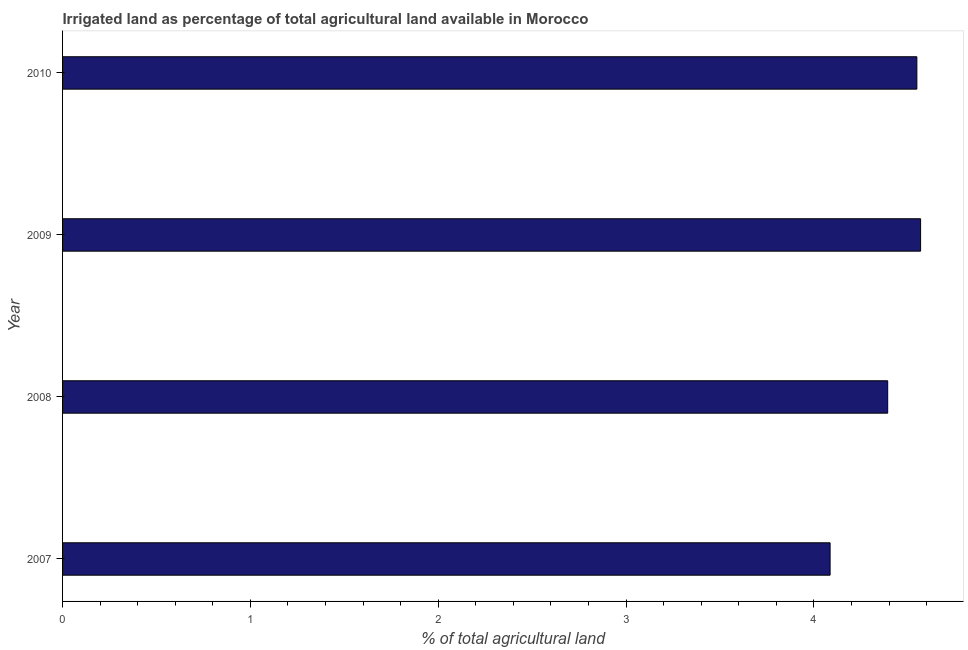What is the title of the graph?
Offer a terse response. Irrigated land as percentage of total agricultural land available in Morocco. What is the label or title of the X-axis?
Make the answer very short. % of total agricultural land. What is the label or title of the Y-axis?
Your answer should be very brief. Year. What is the percentage of agricultural irrigated land in 2008?
Ensure brevity in your answer.  4.39. Across all years, what is the maximum percentage of agricultural irrigated land?
Provide a succinct answer. 4.57. Across all years, what is the minimum percentage of agricultural irrigated land?
Your answer should be very brief. 4.09. What is the sum of the percentage of agricultural irrigated land?
Make the answer very short. 17.59. What is the difference between the percentage of agricultural irrigated land in 2008 and 2009?
Ensure brevity in your answer.  -0.17. What is the average percentage of agricultural irrigated land per year?
Ensure brevity in your answer.  4.4. What is the median percentage of agricultural irrigated land?
Give a very brief answer. 4.47. In how many years, is the percentage of agricultural irrigated land greater than 0.4 %?
Offer a very short reply. 4. What is the ratio of the percentage of agricultural irrigated land in 2007 to that in 2010?
Provide a succinct answer. 0.9. Is the percentage of agricultural irrigated land in 2008 less than that in 2009?
Provide a short and direct response. Yes. Is the difference between the percentage of agricultural irrigated land in 2007 and 2009 greater than the difference between any two years?
Offer a terse response. Yes. Is the sum of the percentage of agricultural irrigated land in 2008 and 2009 greater than the maximum percentage of agricultural irrigated land across all years?
Provide a succinct answer. Yes. What is the difference between the highest and the lowest percentage of agricultural irrigated land?
Your answer should be very brief. 0.48. In how many years, is the percentage of agricultural irrigated land greater than the average percentage of agricultural irrigated land taken over all years?
Offer a terse response. 2. What is the difference between two consecutive major ticks on the X-axis?
Your answer should be compact. 1. Are the values on the major ticks of X-axis written in scientific E-notation?
Provide a succinct answer. No. What is the % of total agricultural land of 2007?
Make the answer very short. 4.09. What is the % of total agricultural land of 2008?
Provide a succinct answer. 4.39. What is the % of total agricultural land in 2009?
Offer a very short reply. 4.57. What is the % of total agricultural land in 2010?
Make the answer very short. 4.55. What is the difference between the % of total agricultural land in 2007 and 2008?
Provide a succinct answer. -0.31. What is the difference between the % of total agricultural land in 2007 and 2009?
Make the answer very short. -0.48. What is the difference between the % of total agricultural land in 2007 and 2010?
Provide a succinct answer. -0.46. What is the difference between the % of total agricultural land in 2008 and 2009?
Provide a short and direct response. -0.18. What is the difference between the % of total agricultural land in 2008 and 2010?
Make the answer very short. -0.16. What is the difference between the % of total agricultural land in 2009 and 2010?
Your answer should be very brief. 0.02. What is the ratio of the % of total agricultural land in 2007 to that in 2009?
Make the answer very short. 0.9. What is the ratio of the % of total agricultural land in 2007 to that in 2010?
Provide a short and direct response. 0.9. What is the ratio of the % of total agricultural land in 2008 to that in 2009?
Provide a succinct answer. 0.96. 